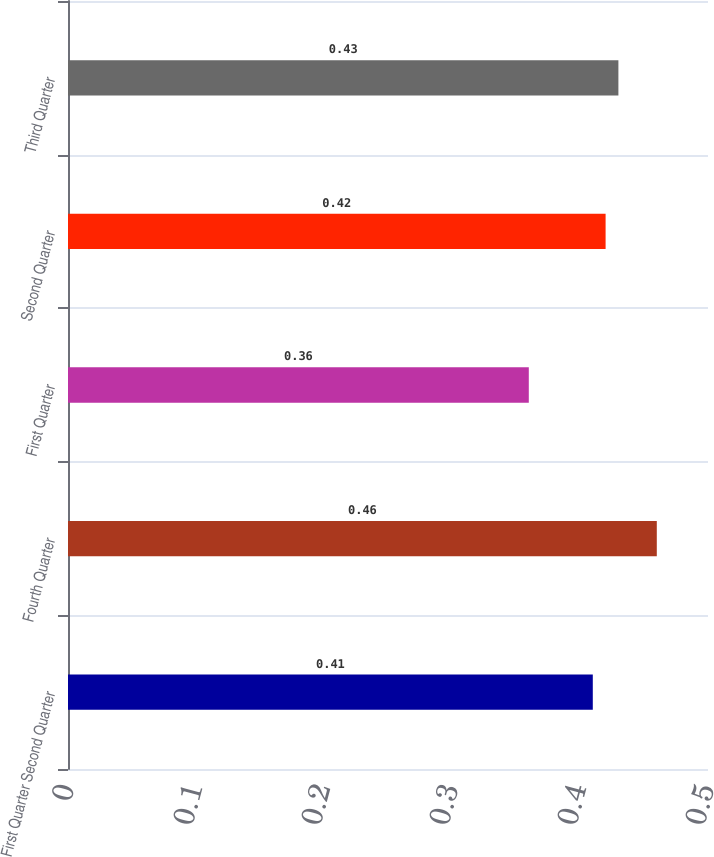Convert chart to OTSL. <chart><loc_0><loc_0><loc_500><loc_500><bar_chart><fcel>First Quarter Second Quarter<fcel>Fourth Quarter<fcel>First Quarter<fcel>Second Quarter<fcel>Third Quarter<nl><fcel>0.41<fcel>0.46<fcel>0.36<fcel>0.42<fcel>0.43<nl></chart> 